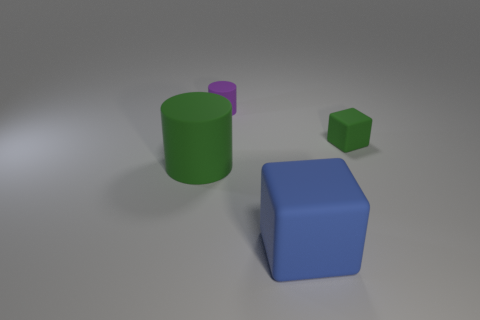Describe the texture of the objects. The objects seem to have a matte surface, as there is no significant reflection or glossiness visible. They bear a uniform color and texture that indicates a simplistic rendering, likely from a computer graphics program. 